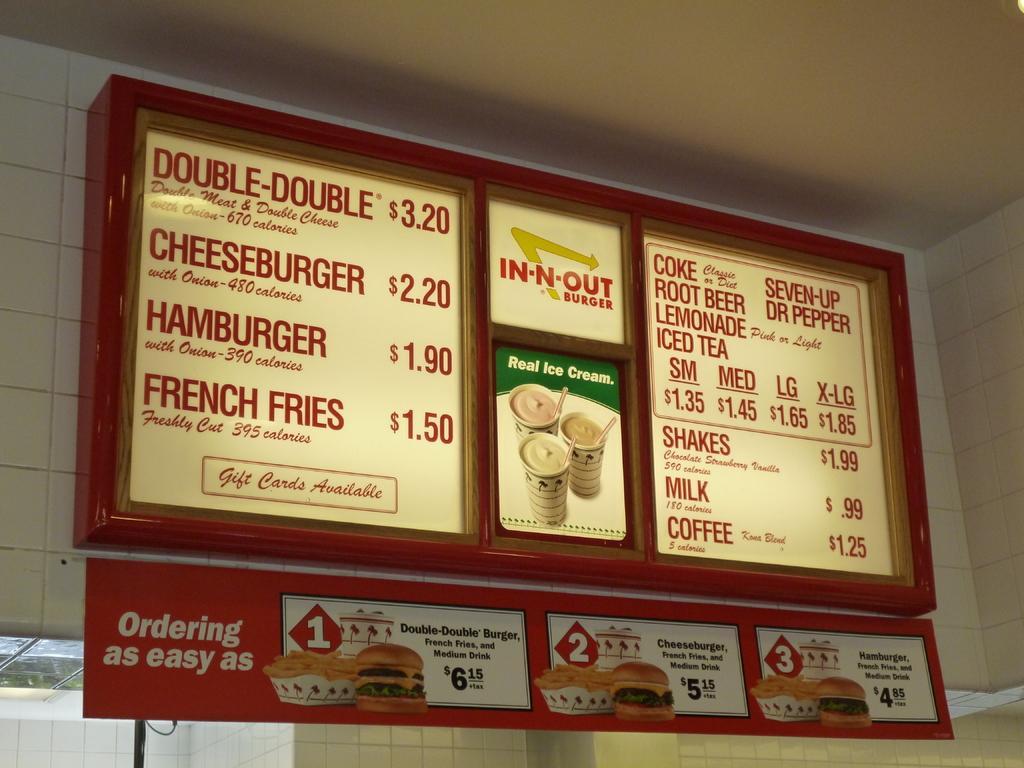Could you give a brief overview of what you see in this image? In the center of the image we can see a board is present on the wall. On the board we can see the text and food items. In the bottom left corner we can see a window. At the top of the image we can see the roof. 